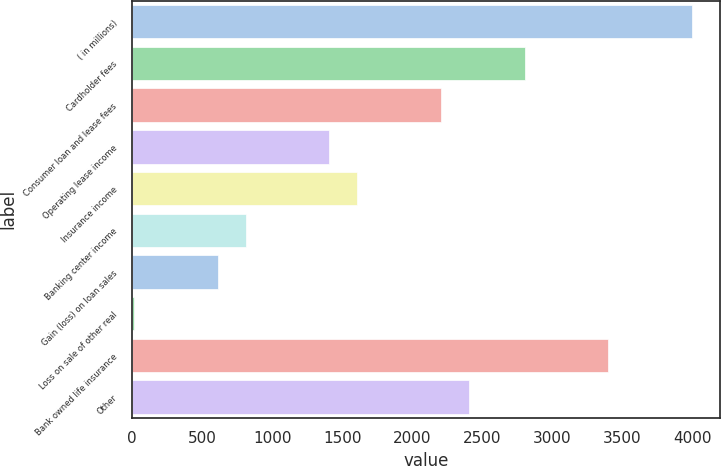Convert chart. <chart><loc_0><loc_0><loc_500><loc_500><bar_chart><fcel>( in millions)<fcel>Cardholder fees<fcel>Consumer loan and lease fees<fcel>Operating lease income<fcel>Insurance income<fcel>Banking center income<fcel>Gain (loss) on loan sales<fcel>Loss on sale of other real<fcel>Bank owned life insurance<fcel>Other<nl><fcel>4000<fcel>2804.2<fcel>2206.3<fcel>1409.1<fcel>1608.4<fcel>811.2<fcel>611.9<fcel>14<fcel>3402.1<fcel>2405.6<nl></chart> 